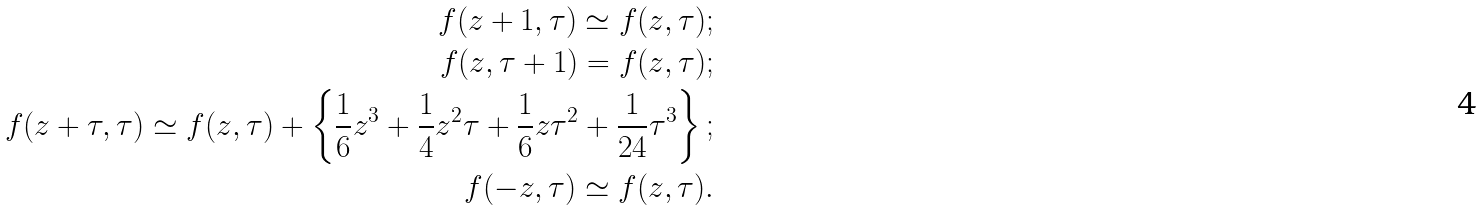Convert formula to latex. <formula><loc_0><loc_0><loc_500><loc_500>f ( z + 1 , \tau ) \simeq f ( z , \tau ) ; \\ f ( z , \tau + 1 ) = f ( z , \tau ) ; \\ f ( z + \tau , \tau ) \simeq f ( z , \tau ) + \left \{ \frac { 1 } { 6 } z ^ { 3 } + \frac { 1 } { 4 } z ^ { 2 } \tau + \frac { 1 } { 6 } z \tau ^ { 2 } + \frac { 1 } { 2 4 } \tau ^ { 3 } \right \} ; \\ f ( - z , \tau ) \simeq f ( z , \tau ) .</formula> 